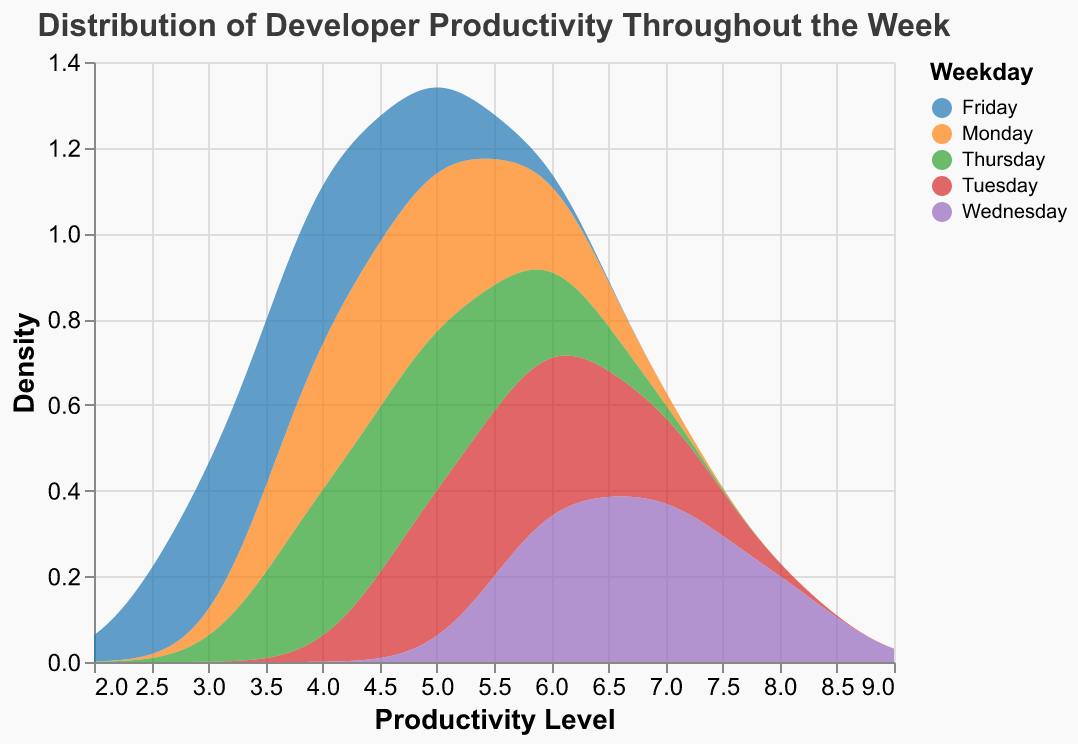What's the title of the figure? The title of the figure is located at the top and describes the overall content of the plot.
Answer: Distribution of Developer Productivity Throughout the Week How many different days are shown in the figure? By examining the legend or color code used in the plot, you can identify the number of distinct days represented.
Answer: Five (Monday to Friday) Which day shows the highest density of productivity levels? Look for the peak (highest point) of the density curve for each day and identify which day has the overall highest peak.
Answer: Wednesday Which day has the lowest density peak in productivity levels? Observe the curves and identify the curve with the lowest peak among all days.
Answer: Friday On which day is the productivity level most spread out across different levels? Check the width of the density curves to see which day has a broader spread from minimum to maximum productivity levels.
Answer: Wednesday What is the range of productivity levels displayed on the x-axis? The x-axis range is determined by the extent values specified in the plot and visible as the boundaries of the axis.
Answer: 2 to 9 Which day has two color-coded productivity levels with the same density? Find any day that has multiple peaks or areas in the density curve reaching the same level.
Answer: Thursday On which day is the productivity level of 4 most frequent? Check where the peaks for productivity level 4 occur across different days.
Answer: Monday What's the difference in the highest productivity density between Wednesday and Monday? Determine the peak density values for Wednesday and Monday, then subtract Monday's peak from Wednesday's peak.
Answer: Given the highest density on Wednesday is visibly higher than Monday, the difference explains the productivity spike mid-week How does the productivity distribution on Tuesday compare to Friday? Look at the shapes and heights of the curves for Tuesday and Friday to compare their density distributions and identify similarities and differences in productivity patterns.
Answer: Tuesday shows a higher and more consistent distribution across higher productivity levels, while Friday has lower density peaking at lower productivity levels 